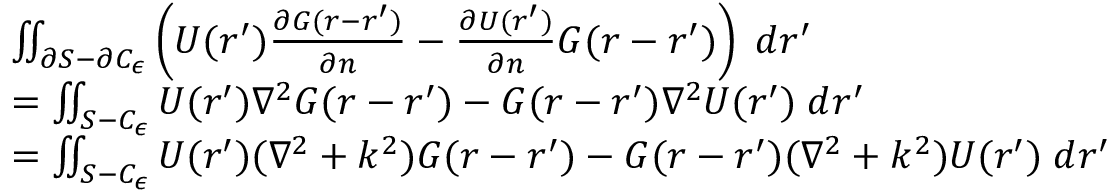<formula> <loc_0><loc_0><loc_500><loc_500>\begin{array} { r l } & { \iint _ { \partial S - \partial C _ { \epsilon } } \left ( U ( r ^ { \prime } ) \frac { \partial G ( r - r ^ { \prime } ) } { \partial n } - \frac { \partial U ( r ^ { \prime } ) } { \partial n } G ( r - r ^ { \prime } ) \right ) \, d r ^ { \prime } } \\ & { = \iint _ { S - C _ { \epsilon } } U ( r ^ { \prime } ) \nabla ^ { 2 } G ( r - r ^ { \prime } ) - G ( r - r ^ { \prime } ) \nabla ^ { 2 } U ( r ^ { \prime } ) \, d r ^ { \prime } } \\ & { = \iint _ { S - C _ { \epsilon } } U ( r ^ { \prime } ) ( \nabla ^ { 2 } + k ^ { 2 } ) G ( r - r ^ { \prime } ) - G ( r - r ^ { \prime } ) ( \nabla ^ { 2 } + k ^ { 2 } ) U ( r ^ { \prime } ) \, d r ^ { \prime } } \end{array}</formula> 